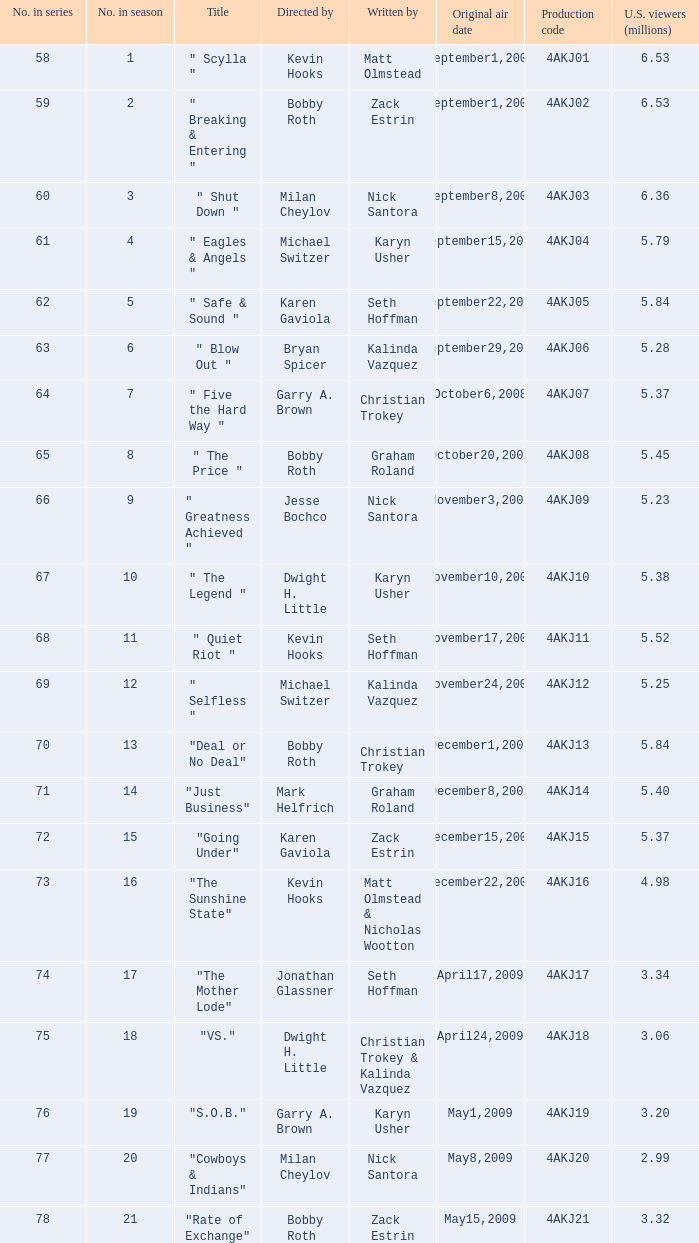Who directed the episode with production code 4akj01? Kevin Hooks. 